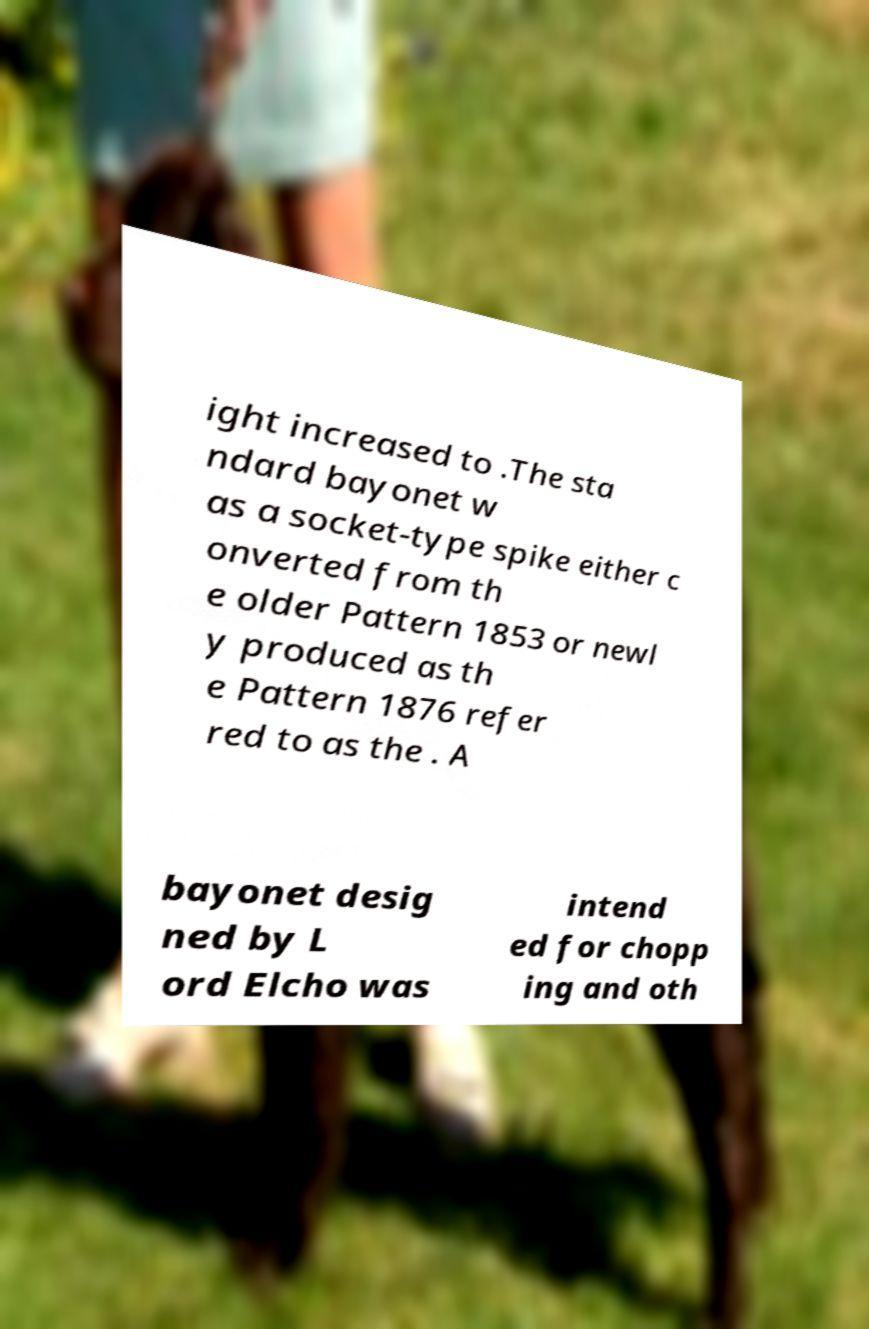Can you accurately transcribe the text from the provided image for me? ight increased to .The sta ndard bayonet w as a socket-type spike either c onverted from th e older Pattern 1853 or newl y produced as th e Pattern 1876 refer red to as the . A bayonet desig ned by L ord Elcho was intend ed for chopp ing and oth 